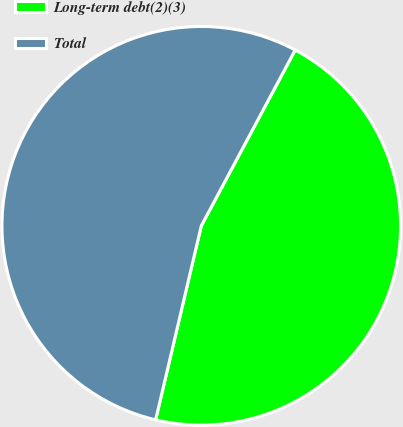Convert chart to OTSL. <chart><loc_0><loc_0><loc_500><loc_500><pie_chart><fcel>Long-term debt(2)(3)<fcel>Total<nl><fcel>45.87%<fcel>54.13%<nl></chart> 